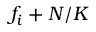Convert formula to latex. <formula><loc_0><loc_0><loc_500><loc_500>f _ { i } + N / K</formula> 